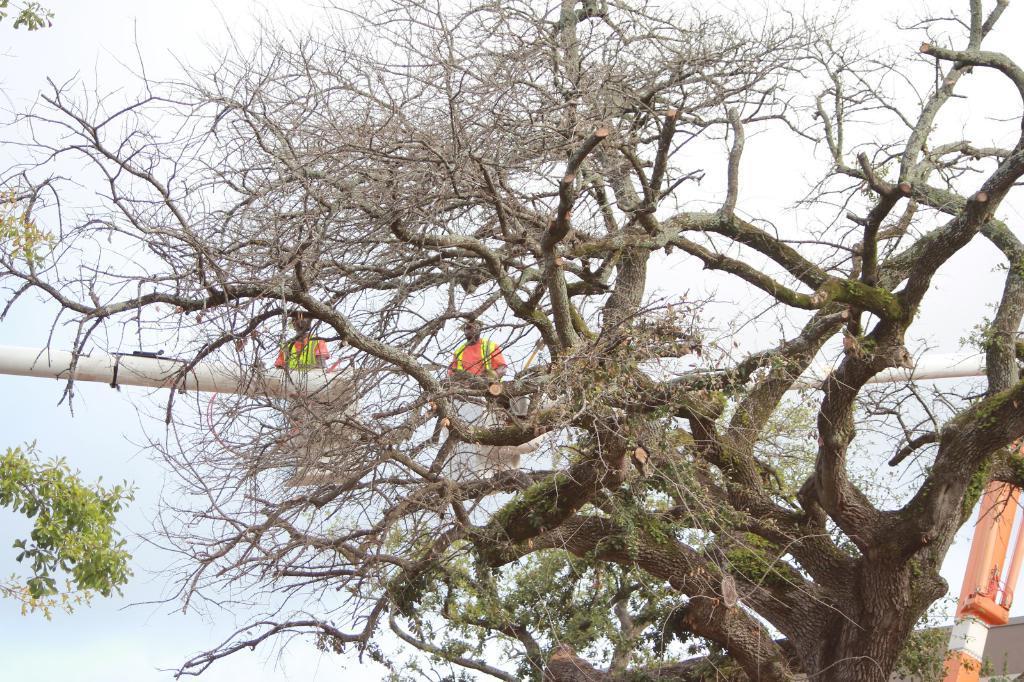How would you summarize this image in a sentence or two? In the center of the image we can see a tree. In the middle of the image we can see two persons present on the rod. On the right side of the image a machine is there. In the background of the image there is a sky. 